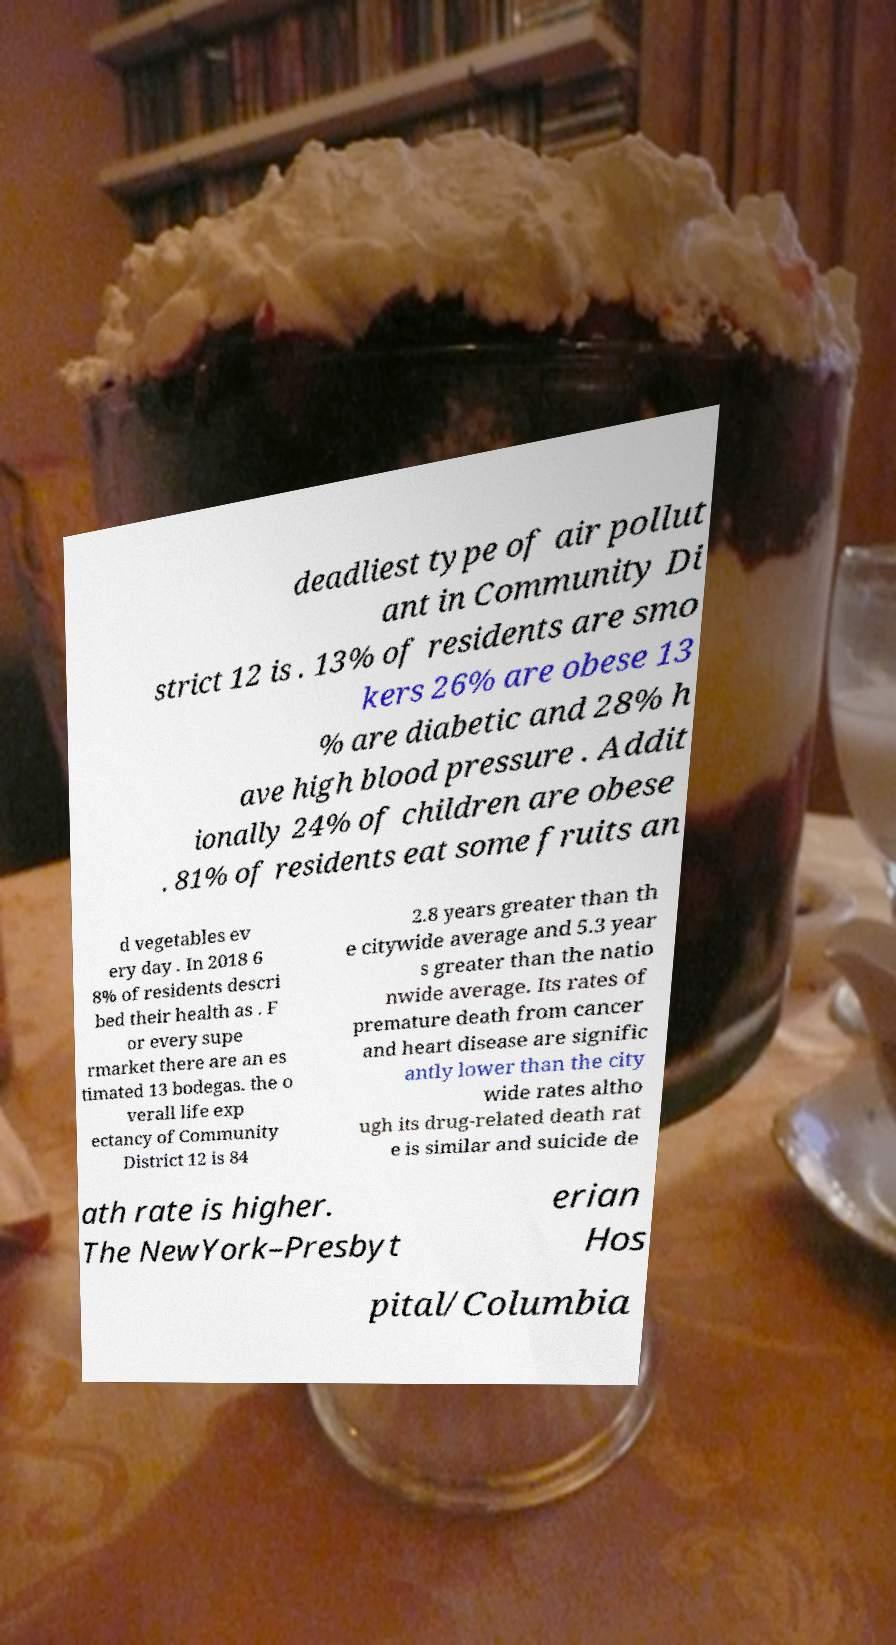Could you assist in decoding the text presented in this image and type it out clearly? deadliest type of air pollut ant in Community Di strict 12 is . 13% of residents are smo kers 26% are obese 13 % are diabetic and 28% h ave high blood pressure . Addit ionally 24% of children are obese . 81% of residents eat some fruits an d vegetables ev ery day . In 2018 6 8% of residents descri bed their health as . F or every supe rmarket there are an es timated 13 bodegas. the o verall life exp ectancy of Community District 12 is 84 2.8 years greater than th e citywide average and 5.3 year s greater than the natio nwide average. Its rates of premature death from cancer and heart disease are signific antly lower than the city wide rates altho ugh its drug-related death rat e is similar and suicide de ath rate is higher. The NewYork–Presbyt erian Hos pital/Columbia 